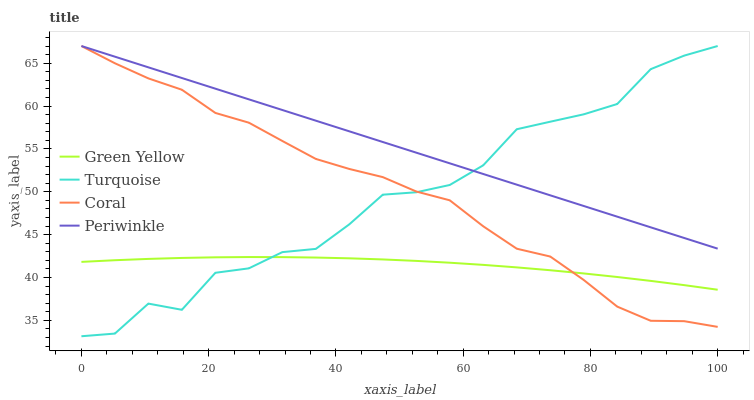Does Periwinkle have the minimum area under the curve?
Answer yes or no. No. Does Green Yellow have the maximum area under the curve?
Answer yes or no. No. Is Green Yellow the smoothest?
Answer yes or no. No. Is Green Yellow the roughest?
Answer yes or no. No. Does Green Yellow have the lowest value?
Answer yes or no. No. Does Green Yellow have the highest value?
Answer yes or no. No. Is Green Yellow less than Periwinkle?
Answer yes or no. Yes. Is Periwinkle greater than Green Yellow?
Answer yes or no. Yes. Does Green Yellow intersect Periwinkle?
Answer yes or no. No. 